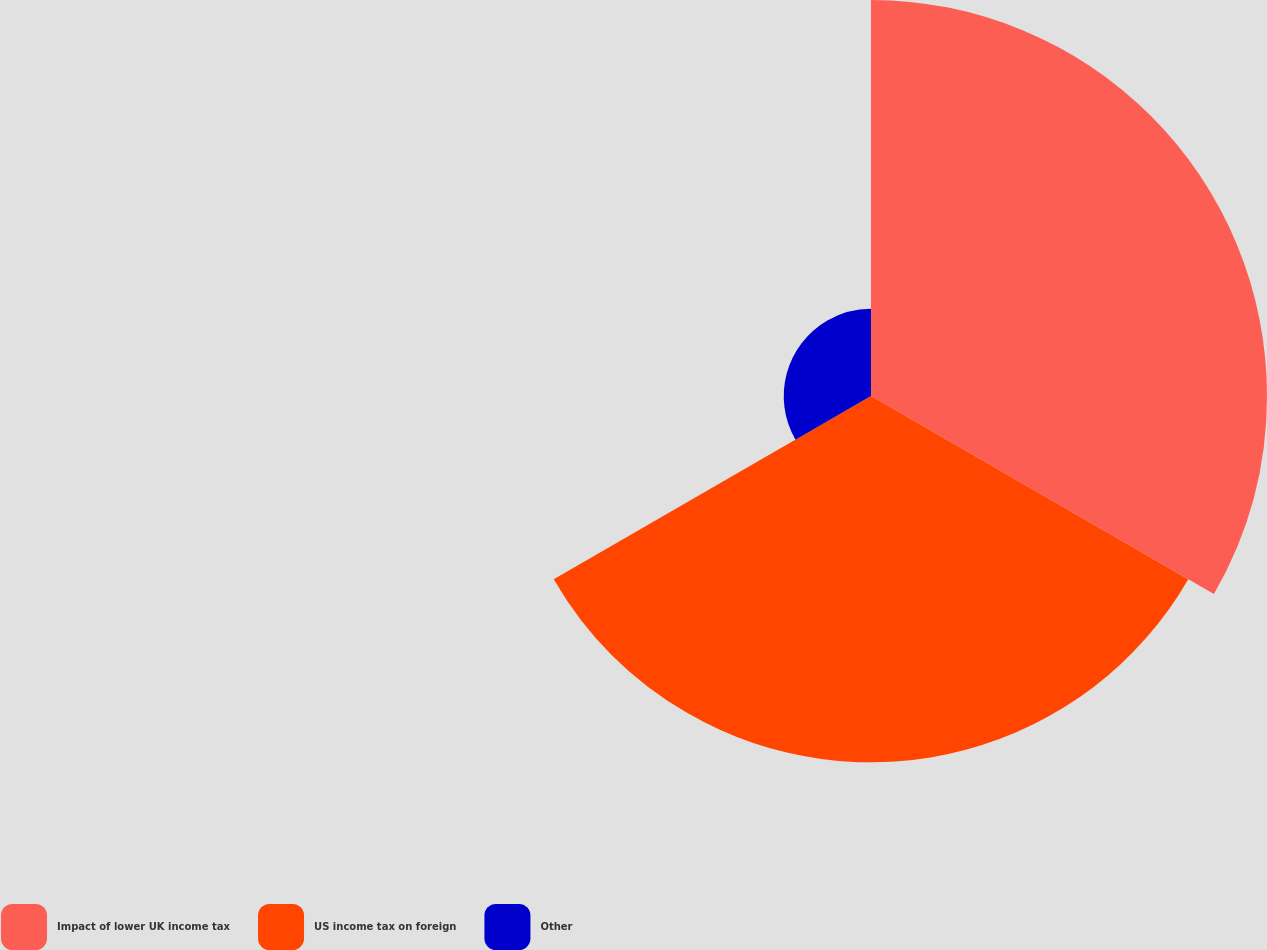Convert chart to OTSL. <chart><loc_0><loc_0><loc_500><loc_500><pie_chart><fcel>Impact of lower UK income tax<fcel>US income tax on foreign<fcel>Other<nl><fcel>46.61%<fcel>43.12%<fcel>10.27%<nl></chart> 